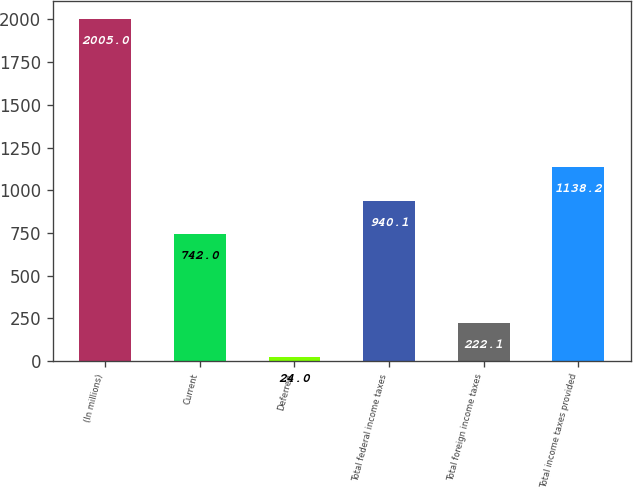Convert chart. <chart><loc_0><loc_0><loc_500><loc_500><bar_chart><fcel>(In millions)<fcel>Current<fcel>Deferred<fcel>Total federal income taxes<fcel>Total foreign income taxes<fcel>Total income taxes provided<nl><fcel>2005<fcel>742<fcel>24<fcel>940.1<fcel>222.1<fcel>1138.2<nl></chart> 